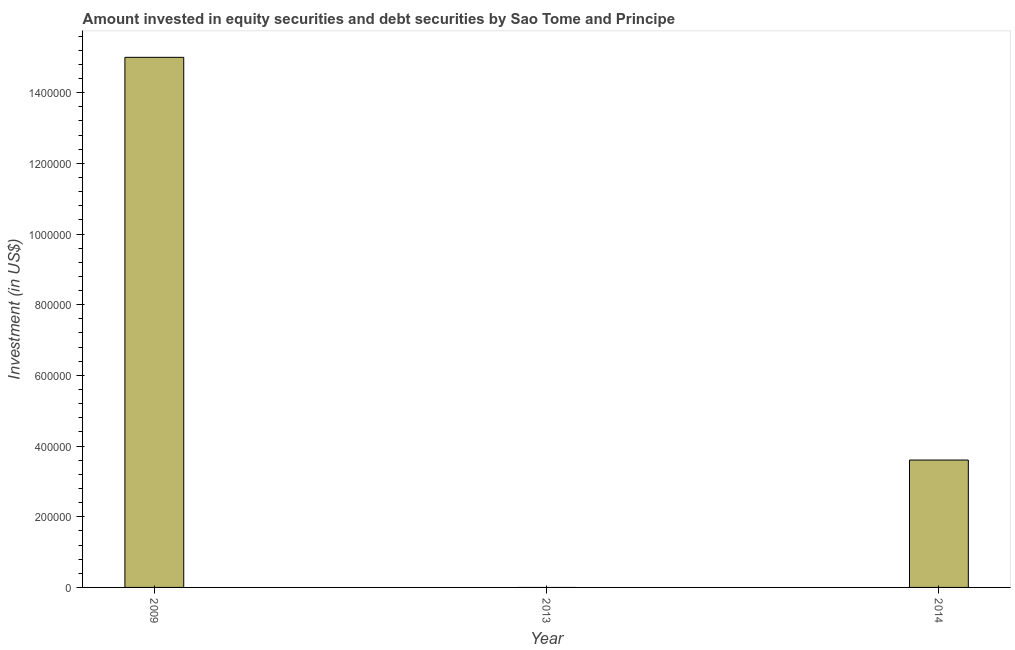Does the graph contain grids?
Keep it short and to the point. No. What is the title of the graph?
Your answer should be very brief. Amount invested in equity securities and debt securities by Sao Tome and Principe. What is the label or title of the X-axis?
Offer a terse response. Year. What is the label or title of the Y-axis?
Provide a short and direct response. Investment (in US$). What is the portfolio investment in 2009?
Keep it short and to the point. 1.50e+06. Across all years, what is the maximum portfolio investment?
Ensure brevity in your answer.  1.50e+06. What is the sum of the portfolio investment?
Offer a very short reply. 1.86e+06. What is the difference between the portfolio investment in 2009 and 2014?
Your response must be concise. 1.14e+06. What is the average portfolio investment per year?
Keep it short and to the point. 6.20e+05. What is the median portfolio investment?
Provide a short and direct response. 3.60e+05. Is the difference between the portfolio investment in 2009 and 2014 greater than the difference between any two years?
Provide a short and direct response. No. Is the sum of the portfolio investment in 2009 and 2014 greater than the maximum portfolio investment across all years?
Make the answer very short. Yes. What is the difference between the highest and the lowest portfolio investment?
Offer a terse response. 1.50e+06. How many bars are there?
Offer a terse response. 2. Are the values on the major ticks of Y-axis written in scientific E-notation?
Your response must be concise. No. What is the Investment (in US$) of 2009?
Keep it short and to the point. 1.50e+06. What is the Investment (in US$) in 2014?
Provide a succinct answer. 3.60e+05. What is the difference between the Investment (in US$) in 2009 and 2014?
Keep it short and to the point. 1.14e+06. What is the ratio of the Investment (in US$) in 2009 to that in 2014?
Keep it short and to the point. 4.16. 